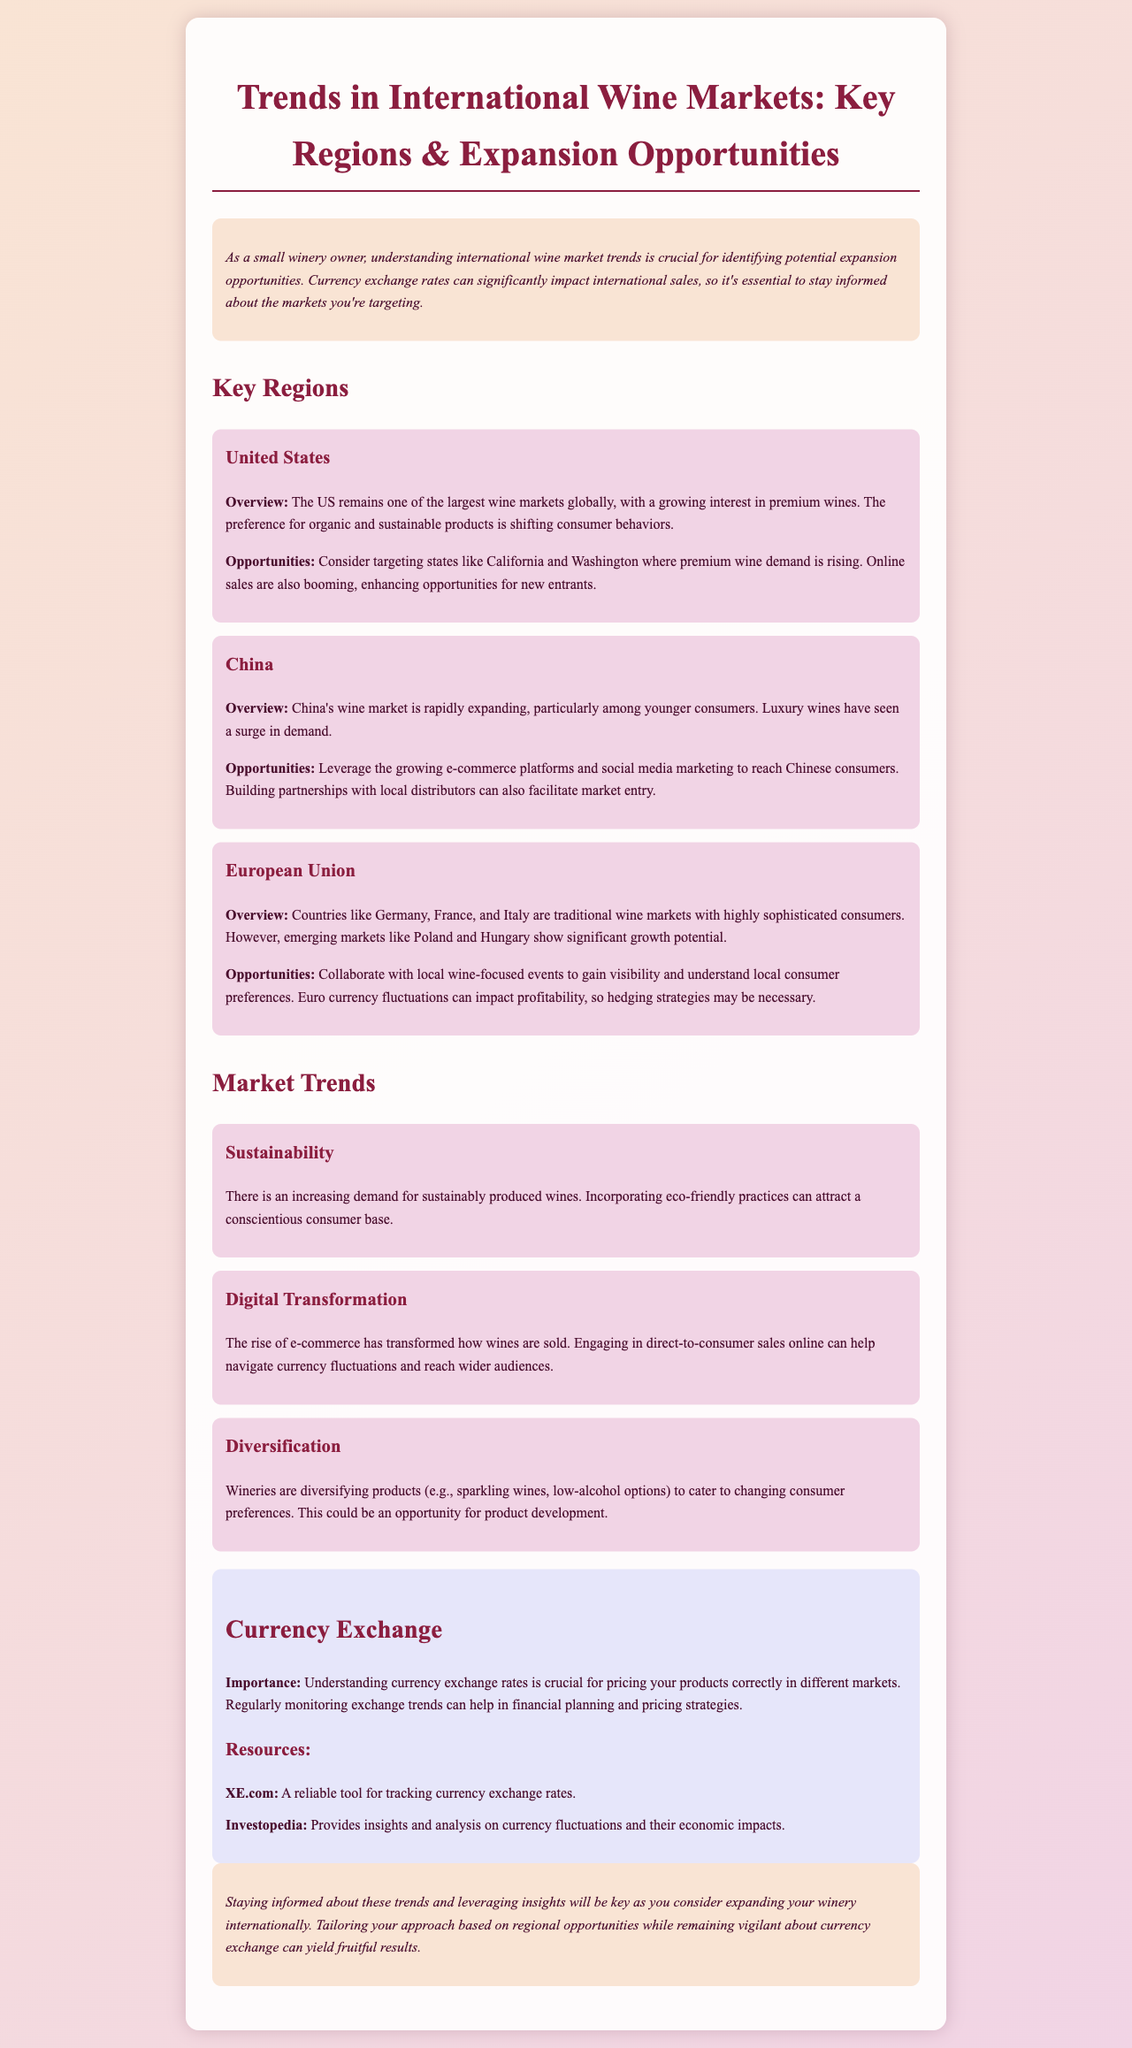What consumer product preference is rising in the US? The document mentions a growing interest in premium wines in the US market.
Answer: Premium wines Which region shows significant growth potential along with traditional markets in the EU? The document states that emerging markets like Poland and Hungary demonstrate significant growth potential.
Answer: Poland and Hungary What practice can attract a conscientious consumer base? The newsletter highlights the demand for sustainably produced wines, which can attract such consumers.
Answer: Sustainability What currency fluctuations may impact profitability in the EU? The document discusses euro currency fluctuations and their potential impact on profitability.
Answer: Euro currency fluctuations Which online tool is recommended for tracking currency exchange rates? The newsletter lists XE.com as a reliable tool for tracking currency exchange rates.
Answer: XE.com What transformation has affected how wines are sold? The document mentions that digital transformation, specifically through e-commerce, has changed the wine selling process.
Answer: Digital transformation What key market is China targeting among younger consumers? The newsletter indicates that luxury wines have seen a surge in demand among younger consumers in China.
Answer: Luxury wines What should wineries monitor for financial planning? The newsletter emphasizes the importance of regularly monitoring currency exchange trends for financial planning.
Answer: Currency exchange trends 